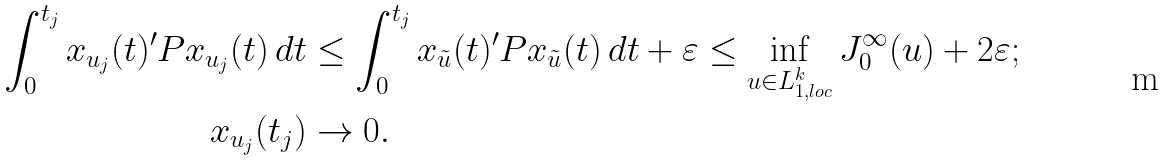<formula> <loc_0><loc_0><loc_500><loc_500>\int _ { 0 } ^ { t _ { j } } x _ { u _ { j } } ( t ) ^ { \prime } P x _ { u _ { j } } ( t ) \, d t & \leq \int _ { 0 } ^ { t _ { j } } x _ { \tilde { u } } ( t ) ^ { \prime } P x _ { \tilde { u } } ( t ) \, d t + \varepsilon \leq \inf _ { u \in L _ { 1 , l o c } ^ { k } } J _ { 0 } ^ { \infty } ( u ) + 2 \varepsilon ; \\ x _ { u _ { j } } ( t _ { j } ) & \rightarrow 0 .</formula> 